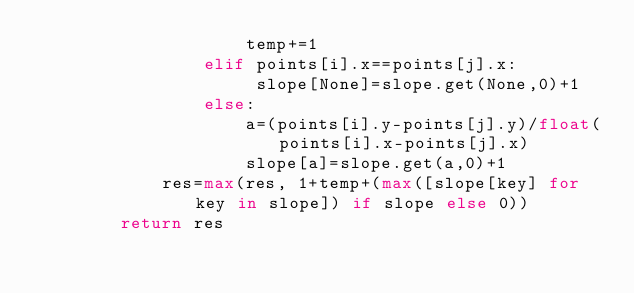<code> <loc_0><loc_0><loc_500><loc_500><_Python_>                    temp+=1
                elif points[i].x==points[j].x:
                     slope[None]=slope.get(None,0)+1
                else:
                    a=(points[i].y-points[j].y)/float(points[i].x-points[j].x)
                    slope[a]=slope.get(a,0)+1
            res=max(res, 1+temp+(max([slope[key] for key in slope]) if slope else 0))
        return res</code> 